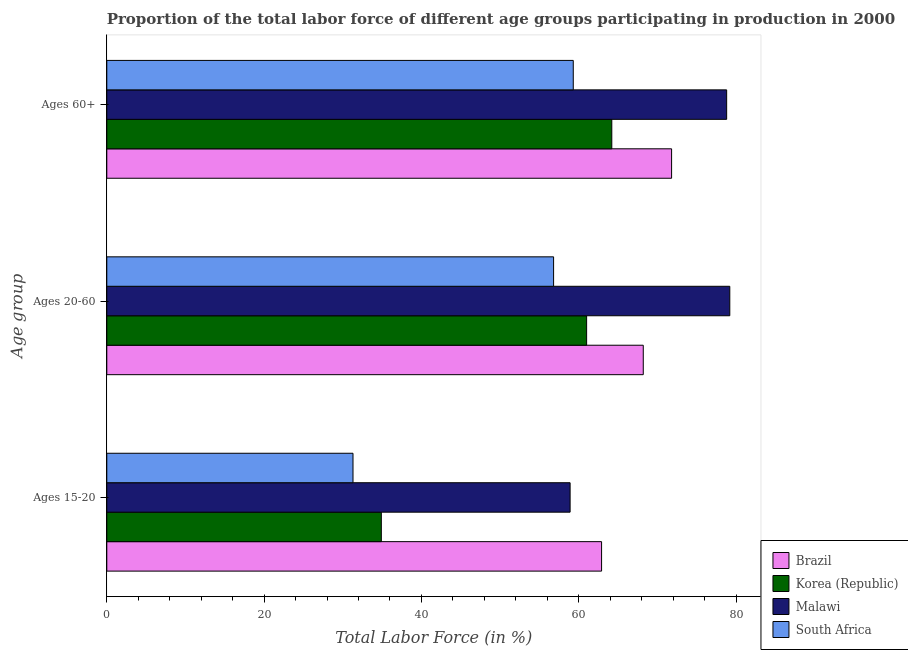How many different coloured bars are there?
Provide a succinct answer. 4. How many groups of bars are there?
Keep it short and to the point. 3. How many bars are there on the 1st tick from the top?
Keep it short and to the point. 4. What is the label of the 1st group of bars from the top?
Make the answer very short. Ages 60+. What is the percentage of labor force within the age group 15-20 in Brazil?
Your response must be concise. 62.9. Across all countries, what is the maximum percentage of labor force above age 60?
Give a very brief answer. 78.8. Across all countries, what is the minimum percentage of labor force within the age group 15-20?
Give a very brief answer. 31.3. In which country was the percentage of labor force within the age group 20-60 maximum?
Make the answer very short. Malawi. In which country was the percentage of labor force within the age group 20-60 minimum?
Provide a short and direct response. South Africa. What is the total percentage of labor force within the age group 15-20 in the graph?
Your response must be concise. 188. What is the difference between the percentage of labor force above age 60 in South Africa and that in Malawi?
Keep it short and to the point. -19.5. What is the difference between the percentage of labor force above age 60 in Korea (Republic) and the percentage of labor force within the age group 15-20 in Malawi?
Give a very brief answer. 5.3. What is the average percentage of labor force above age 60 per country?
Offer a terse response. 68.53. What is the difference between the percentage of labor force within the age group 15-20 and percentage of labor force above age 60 in South Africa?
Make the answer very short. -28. What is the ratio of the percentage of labor force within the age group 20-60 in South Africa to that in Brazil?
Your response must be concise. 0.83. What is the difference between the highest and the lowest percentage of labor force above age 60?
Provide a short and direct response. 19.5. In how many countries, is the percentage of labor force within the age group 20-60 greater than the average percentage of labor force within the age group 20-60 taken over all countries?
Provide a short and direct response. 2. What does the 2nd bar from the top in Ages 15-20 represents?
Keep it short and to the point. Malawi. What does the 3rd bar from the bottom in Ages 20-60 represents?
Offer a terse response. Malawi. Are all the bars in the graph horizontal?
Your answer should be compact. Yes. How many countries are there in the graph?
Your answer should be very brief. 4. Are the values on the major ticks of X-axis written in scientific E-notation?
Your response must be concise. No. What is the title of the graph?
Make the answer very short. Proportion of the total labor force of different age groups participating in production in 2000. Does "Middle income" appear as one of the legend labels in the graph?
Your answer should be very brief. No. What is the label or title of the X-axis?
Your answer should be very brief. Total Labor Force (in %). What is the label or title of the Y-axis?
Your answer should be compact. Age group. What is the Total Labor Force (in %) of Brazil in Ages 15-20?
Ensure brevity in your answer.  62.9. What is the Total Labor Force (in %) in Korea (Republic) in Ages 15-20?
Offer a terse response. 34.9. What is the Total Labor Force (in %) of Malawi in Ages 15-20?
Offer a very short reply. 58.9. What is the Total Labor Force (in %) in South Africa in Ages 15-20?
Offer a terse response. 31.3. What is the Total Labor Force (in %) of Brazil in Ages 20-60?
Your answer should be compact. 68.2. What is the Total Labor Force (in %) of Korea (Republic) in Ages 20-60?
Ensure brevity in your answer.  61. What is the Total Labor Force (in %) of Malawi in Ages 20-60?
Your response must be concise. 79.2. What is the Total Labor Force (in %) of South Africa in Ages 20-60?
Your answer should be compact. 56.8. What is the Total Labor Force (in %) of Brazil in Ages 60+?
Provide a short and direct response. 71.8. What is the Total Labor Force (in %) in Korea (Republic) in Ages 60+?
Your answer should be very brief. 64.2. What is the Total Labor Force (in %) in Malawi in Ages 60+?
Provide a succinct answer. 78.8. What is the Total Labor Force (in %) of South Africa in Ages 60+?
Provide a succinct answer. 59.3. Across all Age group, what is the maximum Total Labor Force (in %) of Brazil?
Offer a terse response. 71.8. Across all Age group, what is the maximum Total Labor Force (in %) of Korea (Republic)?
Give a very brief answer. 64.2. Across all Age group, what is the maximum Total Labor Force (in %) of Malawi?
Ensure brevity in your answer.  79.2. Across all Age group, what is the maximum Total Labor Force (in %) in South Africa?
Make the answer very short. 59.3. Across all Age group, what is the minimum Total Labor Force (in %) of Brazil?
Make the answer very short. 62.9. Across all Age group, what is the minimum Total Labor Force (in %) in Korea (Republic)?
Keep it short and to the point. 34.9. Across all Age group, what is the minimum Total Labor Force (in %) of Malawi?
Offer a terse response. 58.9. Across all Age group, what is the minimum Total Labor Force (in %) of South Africa?
Your answer should be compact. 31.3. What is the total Total Labor Force (in %) of Brazil in the graph?
Your answer should be compact. 202.9. What is the total Total Labor Force (in %) of Korea (Republic) in the graph?
Give a very brief answer. 160.1. What is the total Total Labor Force (in %) of Malawi in the graph?
Your answer should be very brief. 216.9. What is the total Total Labor Force (in %) of South Africa in the graph?
Your answer should be very brief. 147.4. What is the difference between the Total Labor Force (in %) in Korea (Republic) in Ages 15-20 and that in Ages 20-60?
Make the answer very short. -26.1. What is the difference between the Total Labor Force (in %) of Malawi in Ages 15-20 and that in Ages 20-60?
Provide a succinct answer. -20.3. What is the difference between the Total Labor Force (in %) in South Africa in Ages 15-20 and that in Ages 20-60?
Ensure brevity in your answer.  -25.5. What is the difference between the Total Labor Force (in %) of Korea (Republic) in Ages 15-20 and that in Ages 60+?
Keep it short and to the point. -29.3. What is the difference between the Total Labor Force (in %) of Malawi in Ages 15-20 and that in Ages 60+?
Ensure brevity in your answer.  -19.9. What is the difference between the Total Labor Force (in %) of Brazil in Ages 20-60 and that in Ages 60+?
Ensure brevity in your answer.  -3.6. What is the difference between the Total Labor Force (in %) of Korea (Republic) in Ages 20-60 and that in Ages 60+?
Ensure brevity in your answer.  -3.2. What is the difference between the Total Labor Force (in %) of Malawi in Ages 20-60 and that in Ages 60+?
Your answer should be very brief. 0.4. What is the difference between the Total Labor Force (in %) of Brazil in Ages 15-20 and the Total Labor Force (in %) of Korea (Republic) in Ages 20-60?
Your answer should be very brief. 1.9. What is the difference between the Total Labor Force (in %) in Brazil in Ages 15-20 and the Total Labor Force (in %) in Malawi in Ages 20-60?
Offer a very short reply. -16.3. What is the difference between the Total Labor Force (in %) in Korea (Republic) in Ages 15-20 and the Total Labor Force (in %) in Malawi in Ages 20-60?
Keep it short and to the point. -44.3. What is the difference between the Total Labor Force (in %) in Korea (Republic) in Ages 15-20 and the Total Labor Force (in %) in South Africa in Ages 20-60?
Make the answer very short. -21.9. What is the difference between the Total Labor Force (in %) of Brazil in Ages 15-20 and the Total Labor Force (in %) of Korea (Republic) in Ages 60+?
Your answer should be very brief. -1.3. What is the difference between the Total Labor Force (in %) in Brazil in Ages 15-20 and the Total Labor Force (in %) in Malawi in Ages 60+?
Keep it short and to the point. -15.9. What is the difference between the Total Labor Force (in %) of Korea (Republic) in Ages 15-20 and the Total Labor Force (in %) of Malawi in Ages 60+?
Your response must be concise. -43.9. What is the difference between the Total Labor Force (in %) in Korea (Republic) in Ages 15-20 and the Total Labor Force (in %) in South Africa in Ages 60+?
Your response must be concise. -24.4. What is the difference between the Total Labor Force (in %) in Brazil in Ages 20-60 and the Total Labor Force (in %) in Korea (Republic) in Ages 60+?
Ensure brevity in your answer.  4. What is the difference between the Total Labor Force (in %) in Korea (Republic) in Ages 20-60 and the Total Labor Force (in %) in Malawi in Ages 60+?
Provide a short and direct response. -17.8. What is the difference between the Total Labor Force (in %) of Korea (Republic) in Ages 20-60 and the Total Labor Force (in %) of South Africa in Ages 60+?
Provide a short and direct response. 1.7. What is the difference between the Total Labor Force (in %) in Malawi in Ages 20-60 and the Total Labor Force (in %) in South Africa in Ages 60+?
Provide a succinct answer. 19.9. What is the average Total Labor Force (in %) in Brazil per Age group?
Provide a succinct answer. 67.63. What is the average Total Labor Force (in %) in Korea (Republic) per Age group?
Make the answer very short. 53.37. What is the average Total Labor Force (in %) of Malawi per Age group?
Your answer should be compact. 72.3. What is the average Total Labor Force (in %) in South Africa per Age group?
Offer a terse response. 49.13. What is the difference between the Total Labor Force (in %) of Brazil and Total Labor Force (in %) of South Africa in Ages 15-20?
Your answer should be compact. 31.6. What is the difference between the Total Labor Force (in %) of Malawi and Total Labor Force (in %) of South Africa in Ages 15-20?
Your answer should be compact. 27.6. What is the difference between the Total Labor Force (in %) of Brazil and Total Labor Force (in %) of Korea (Republic) in Ages 20-60?
Your response must be concise. 7.2. What is the difference between the Total Labor Force (in %) of Korea (Republic) and Total Labor Force (in %) of Malawi in Ages 20-60?
Make the answer very short. -18.2. What is the difference between the Total Labor Force (in %) of Korea (Republic) and Total Labor Force (in %) of South Africa in Ages 20-60?
Make the answer very short. 4.2. What is the difference between the Total Labor Force (in %) in Malawi and Total Labor Force (in %) in South Africa in Ages 20-60?
Your response must be concise. 22.4. What is the difference between the Total Labor Force (in %) of Brazil and Total Labor Force (in %) of Malawi in Ages 60+?
Ensure brevity in your answer.  -7. What is the difference between the Total Labor Force (in %) of Korea (Republic) and Total Labor Force (in %) of Malawi in Ages 60+?
Offer a terse response. -14.6. What is the ratio of the Total Labor Force (in %) in Brazil in Ages 15-20 to that in Ages 20-60?
Provide a succinct answer. 0.92. What is the ratio of the Total Labor Force (in %) in Korea (Republic) in Ages 15-20 to that in Ages 20-60?
Provide a short and direct response. 0.57. What is the ratio of the Total Labor Force (in %) of Malawi in Ages 15-20 to that in Ages 20-60?
Your response must be concise. 0.74. What is the ratio of the Total Labor Force (in %) in South Africa in Ages 15-20 to that in Ages 20-60?
Ensure brevity in your answer.  0.55. What is the ratio of the Total Labor Force (in %) in Brazil in Ages 15-20 to that in Ages 60+?
Ensure brevity in your answer.  0.88. What is the ratio of the Total Labor Force (in %) in Korea (Republic) in Ages 15-20 to that in Ages 60+?
Make the answer very short. 0.54. What is the ratio of the Total Labor Force (in %) in Malawi in Ages 15-20 to that in Ages 60+?
Give a very brief answer. 0.75. What is the ratio of the Total Labor Force (in %) in South Africa in Ages 15-20 to that in Ages 60+?
Your answer should be compact. 0.53. What is the ratio of the Total Labor Force (in %) of Brazil in Ages 20-60 to that in Ages 60+?
Make the answer very short. 0.95. What is the ratio of the Total Labor Force (in %) in Korea (Republic) in Ages 20-60 to that in Ages 60+?
Your response must be concise. 0.95. What is the ratio of the Total Labor Force (in %) of Malawi in Ages 20-60 to that in Ages 60+?
Ensure brevity in your answer.  1.01. What is the ratio of the Total Labor Force (in %) in South Africa in Ages 20-60 to that in Ages 60+?
Keep it short and to the point. 0.96. What is the difference between the highest and the lowest Total Labor Force (in %) in Korea (Republic)?
Give a very brief answer. 29.3. What is the difference between the highest and the lowest Total Labor Force (in %) of Malawi?
Make the answer very short. 20.3. What is the difference between the highest and the lowest Total Labor Force (in %) in South Africa?
Provide a succinct answer. 28. 